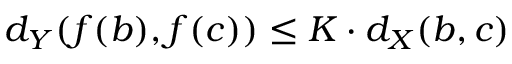<formula> <loc_0><loc_0><loc_500><loc_500>d _ { Y } ( f ( b ) , f ( c ) ) \leq K \cdot d _ { X } ( b , c )</formula> 